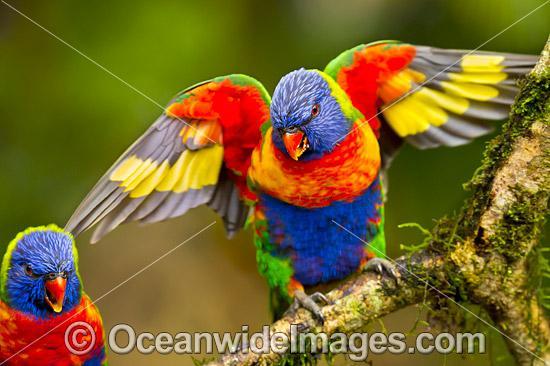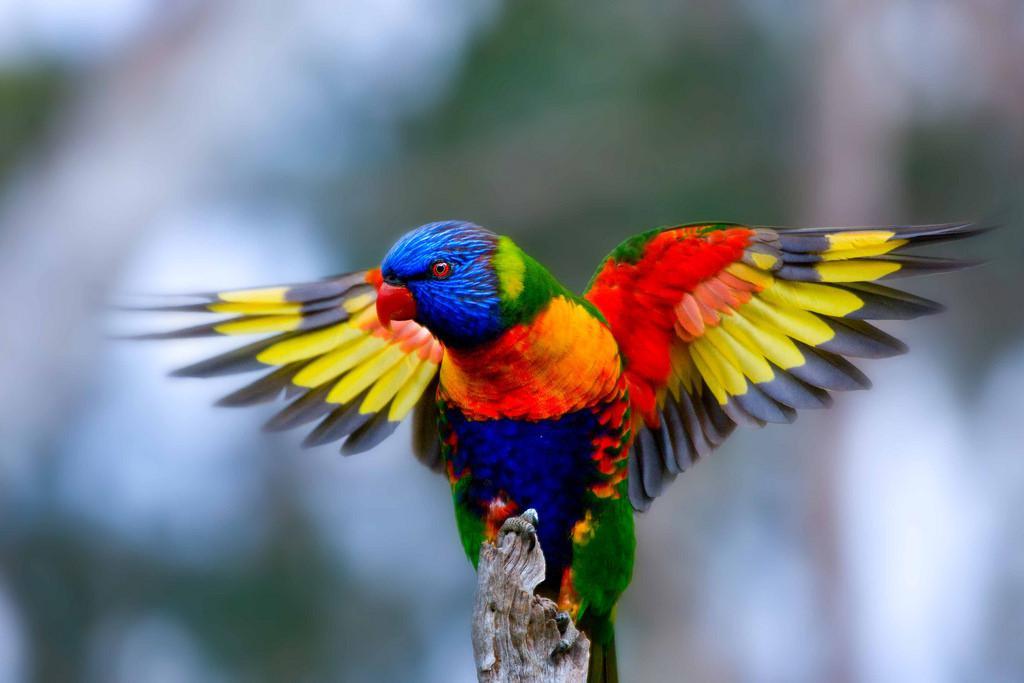The first image is the image on the left, the second image is the image on the right. Given the left and right images, does the statement "There are four birds perched together in groups of two." hold true? Answer yes or no. No. The first image is the image on the left, the second image is the image on the right. Examine the images to the left and right. Is the description "At least one image shows a colorful bird with its wings spread" accurate? Answer yes or no. Yes. 